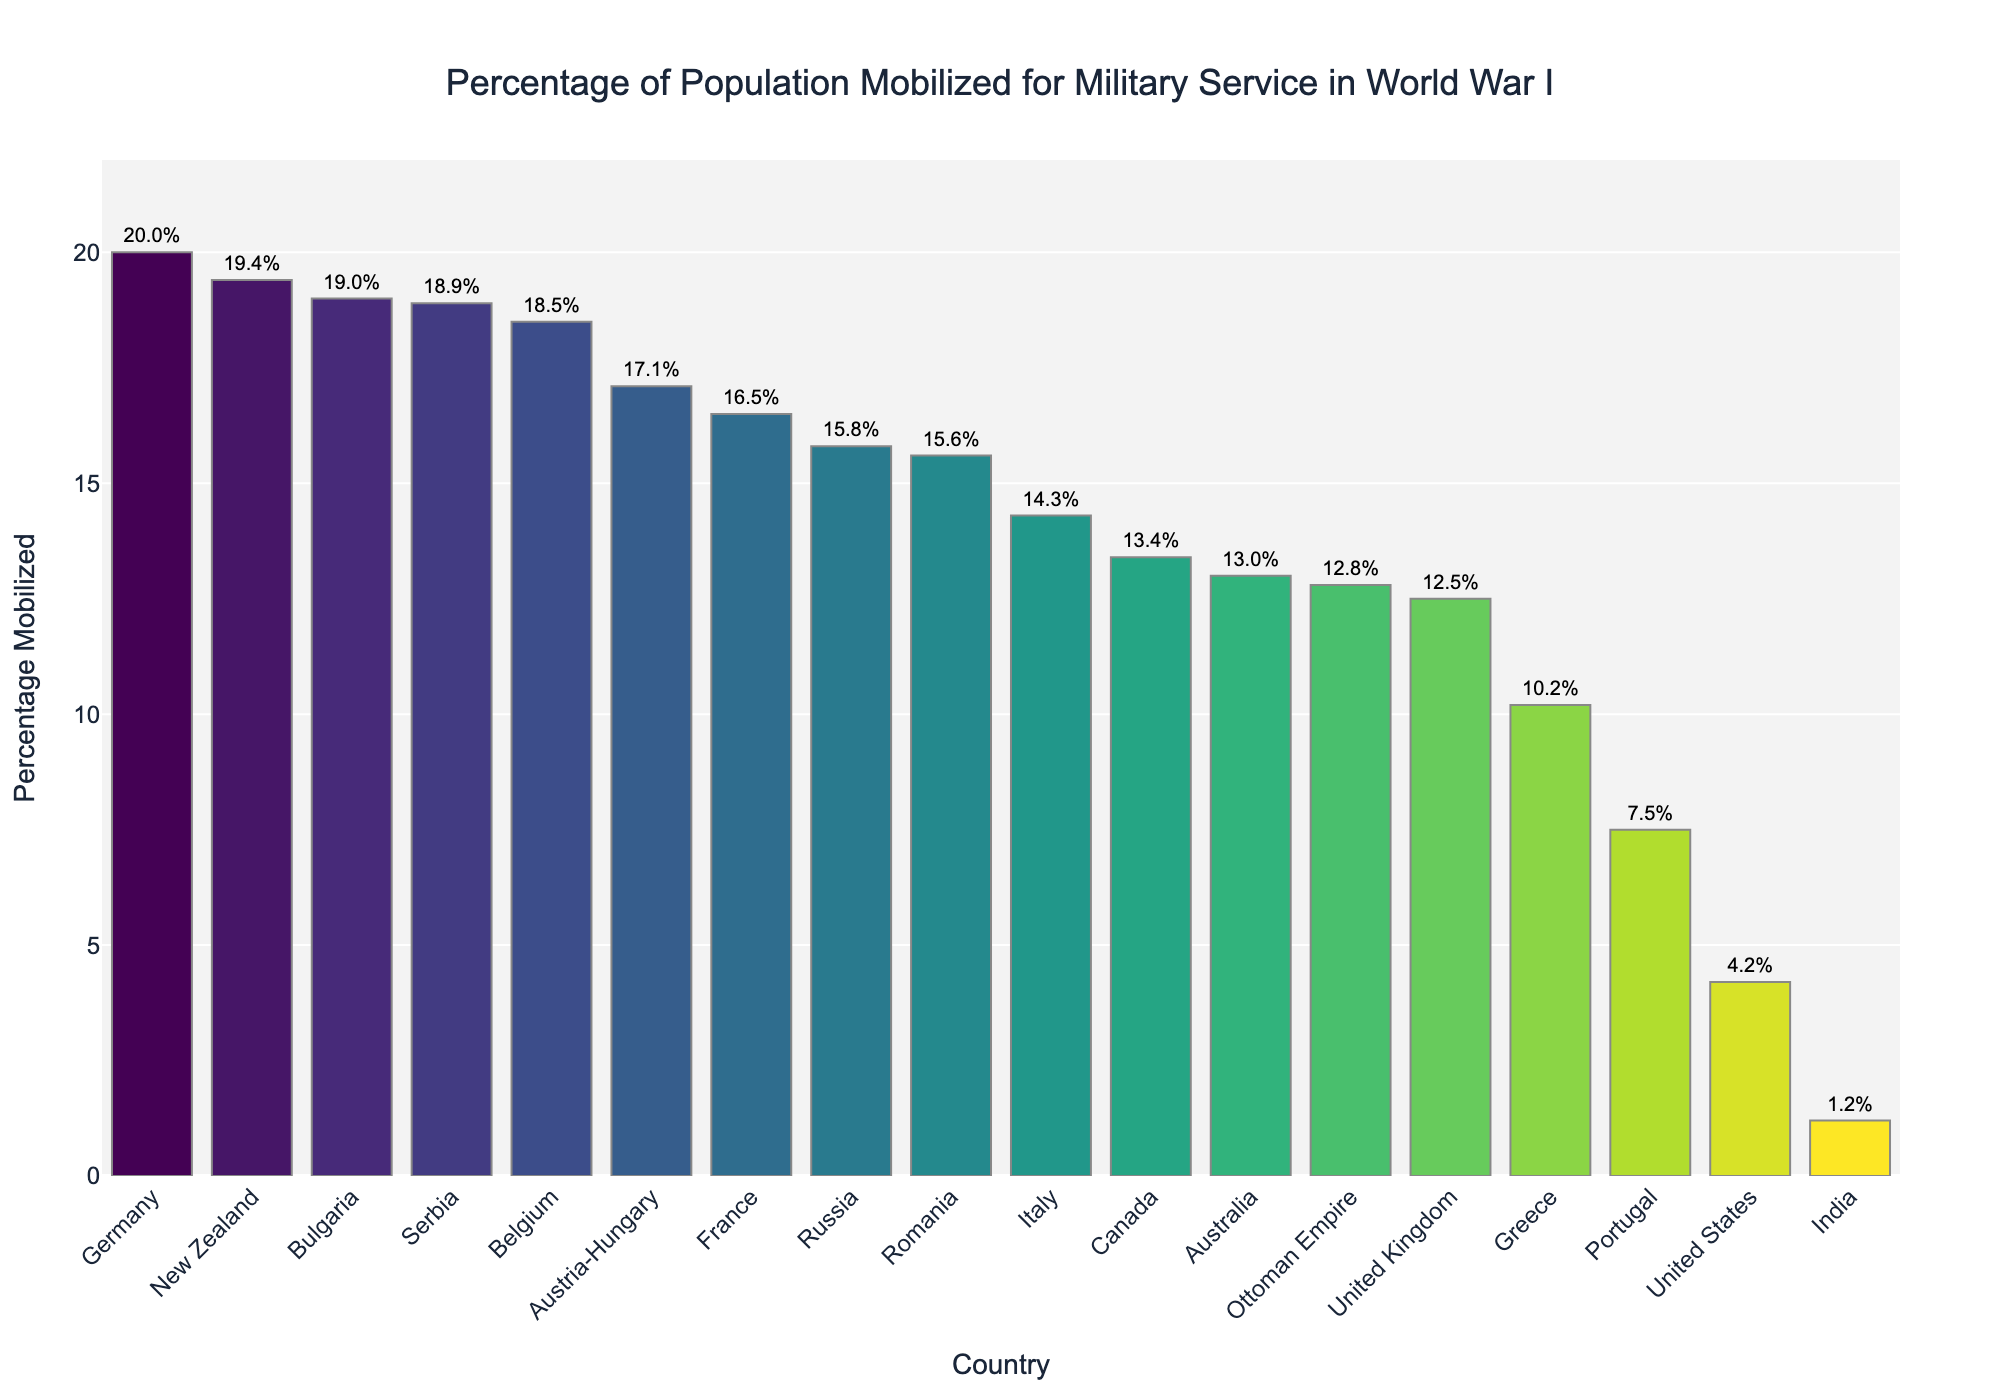Which country had the highest percentage of population mobilized for military service? By examining the figure, the country with the tallest bar is New Zealand, which signifies it had the highest percentage of population mobilized for military service.
Answer: New Zealand What is the difference in the percentage mobilized between the United States and France? From the figure, the bar for France is at 16.5% and the bar for the United States is at 4.2%. The difference is calculated as 16.5% - 4.2% = 12.3%.
Answer: 12.3% How many countries had a percentage mobilization above 15%? By counting the bars that extend above the 15% mark, we see Russia, France, Germany, Austria-Hungary, Serbia, Belgium, Romania, Bulgaria, and New Zealand. There are a total of 9 countries.
Answer: 9 What is the average percentage of mobilization for Germany, Austria-Hungary, and Bulgaria? The percentages for Germany, Austria-Hungary, and Bulgaria are 20.0%, 17.1%, and 19.0%, respectively. The average is calculated by (20.0 + 17.1 + 19.0) / 3 = 18.7%.
Answer: 18.7% Which country had the lowest percentage of population mobilized, and what is the percentage? The bar with the lowest height corresponds to India, which shows a mobilization percentage of 1.2%.
Answer: India, 1.2% How does the percentage of the United Kingdom compare to Canada? According to the figure, the United Kingdom has a percentage mobilization of 12.5%, while Canada has 13.4%. Canada’s mobilization percentage is higher.
Answer: Canada is higher What is the sum of the percentage mobilization for Italy and Australia? The mobilization percentages for Italy and Australia are 14.3% and 13.0%, respectively. The sum is 14.3% + 13.0% = 27.3%.
Answer: 27.3% Which three countries have the closest mobilization percentages, and what are those percentages? By looking for similarly-sized bars, Italy (14.3%), United Kingdom (12.5%), and Ottoman Empire (12.8%) form a closely grouped trio.
Answer: Italy (14.3%), United Kingdom (12.5%), Ottoman Empire (12.8%) What is the median percentage of population mobilized among all the listed countries? To find the median, list all percentages in ascending order and find the middle value. With 18 countries, the median is the average of the 9th and 10th values, which are 15.8% (Russia) and 14.3% (Italy). The median is (15.8 + 14.3) / 2 = 15.05%.
Answer: 15.05% Is the percentage of population mobilized for military service in Greece more or less than Portugal? According to the figure, Greece has a percentage mobilization of 10.2%, and Portugal has 7.5%. Therefore, Greece's mobilization percentage is more than Portugal's.
Answer: More 